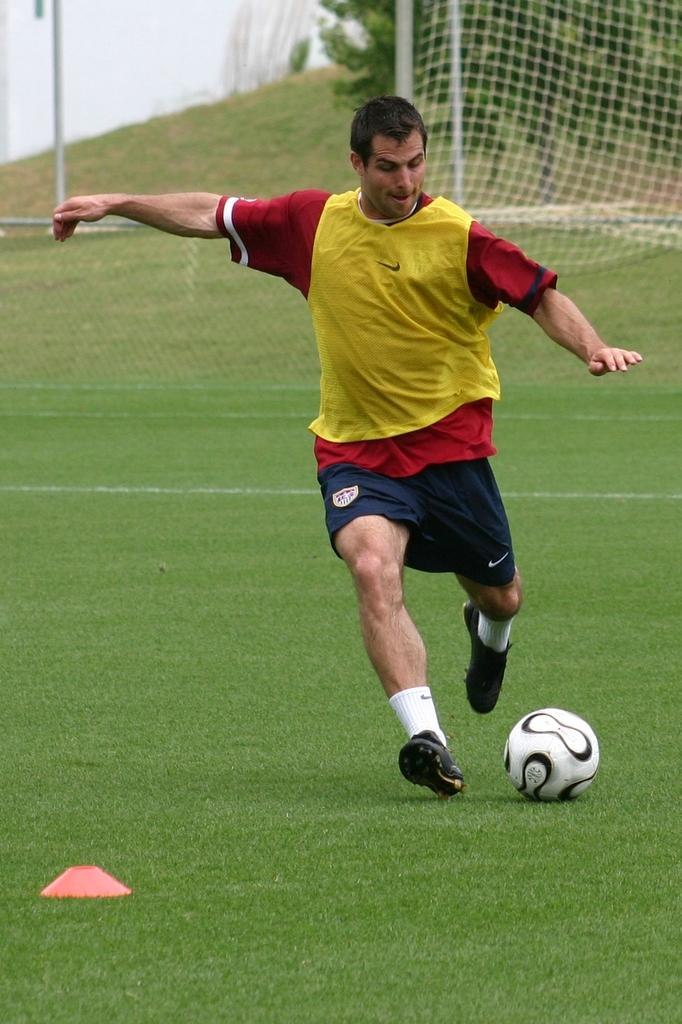What is the person in the image wearing? The person is wearing a yellow, red, and blue dress in the image. What object can be seen in the image besides the person? There is a ball in the image. What color is the object in the garden? There is an orange color object in the garden. What type of barrier is visible in the image? There is net fencing visible in the image. What can be seen in the background of the image? There are trees in the background of the image. What type of appliance is being used in the meeting in the image? There is no meeting or appliance present in the image. 